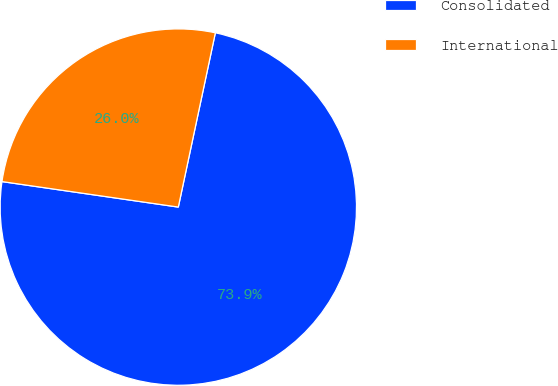<chart> <loc_0><loc_0><loc_500><loc_500><pie_chart><fcel>Consolidated<fcel>International<nl><fcel>73.95%<fcel>26.05%<nl></chart> 